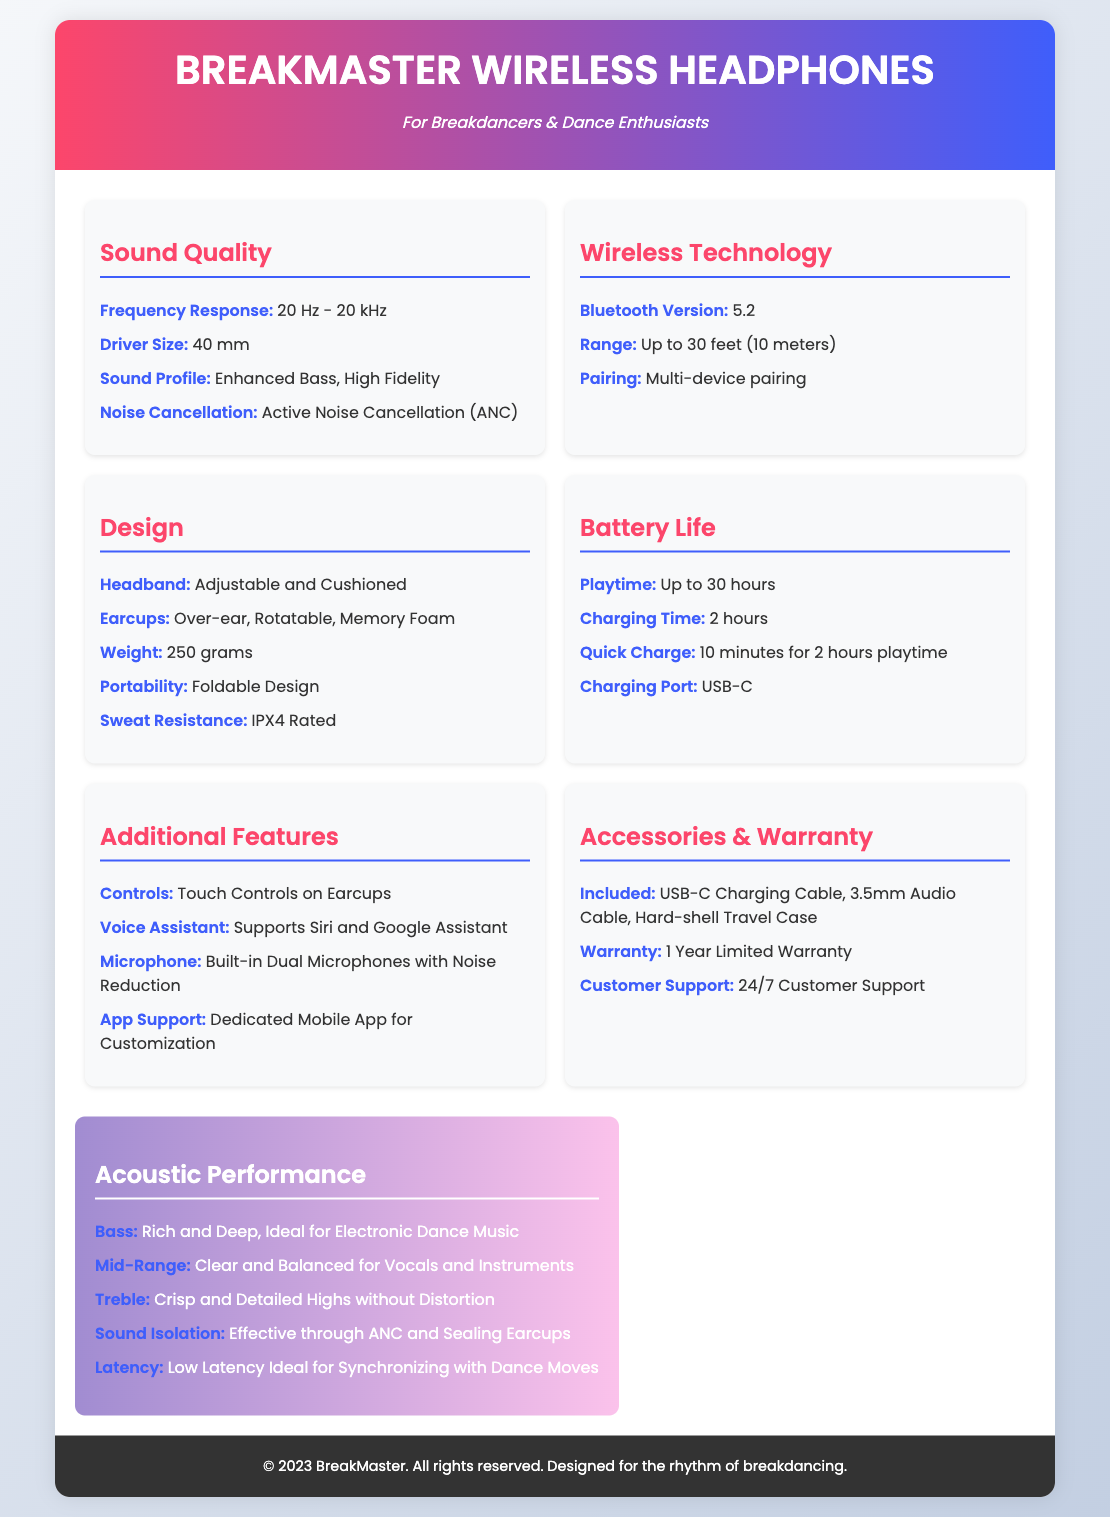what is the frequency response of the headphones? The frequency response is specified in the document as a range from 20 Hz to 20 kHz.
Answer: 20 Hz - 20 kHz what technology does the headphones use for wireless connection? The document states that the headphones use Bluetooth technology, specifically version 5.2.
Answer: Bluetooth 5.2 what is the weight of the BreakMaster Wireless Headphones? The weight of the headphones is provided as 250 grams in the design section of the document.
Answer: 250 grams how long does it take to fully charge the headphones? The charging time to fully charge the headphones is listed as 2 hours in the battery life section.
Answer: 2 hours what additional feature allows for customization of the headphones? According to the document, a dedicated mobile app supports customization.
Answer: Dedicated Mobile App how does the bass quality of the headphones perform? The bass quality is described as rich and deep, ideal for electronic dance music.
Answer: Rich and Deep what is the water resistance rating of the headphones? The sweat resistance rating for the headphones is specified as IPX4.
Answer: IPX4 Rated what is the maximum playtime of the headphones? The maximum playtime before needing a recharge is stated as up to 30 hours.
Answer: Up to 30 hours what kind of support is available for customers? The document mentions that there is 24/7 customer support available.
Answer: 24/7 Customer Support 